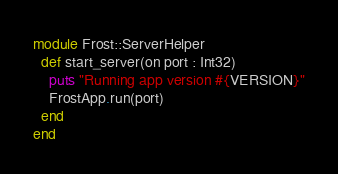Convert code to text. <code><loc_0><loc_0><loc_500><loc_500><_Crystal_>module Frost::ServerHelper
  def start_server(on port : Int32)
    puts "Running app version #{VERSION}"
    FrostApp.run(port)
  end
end
</code> 